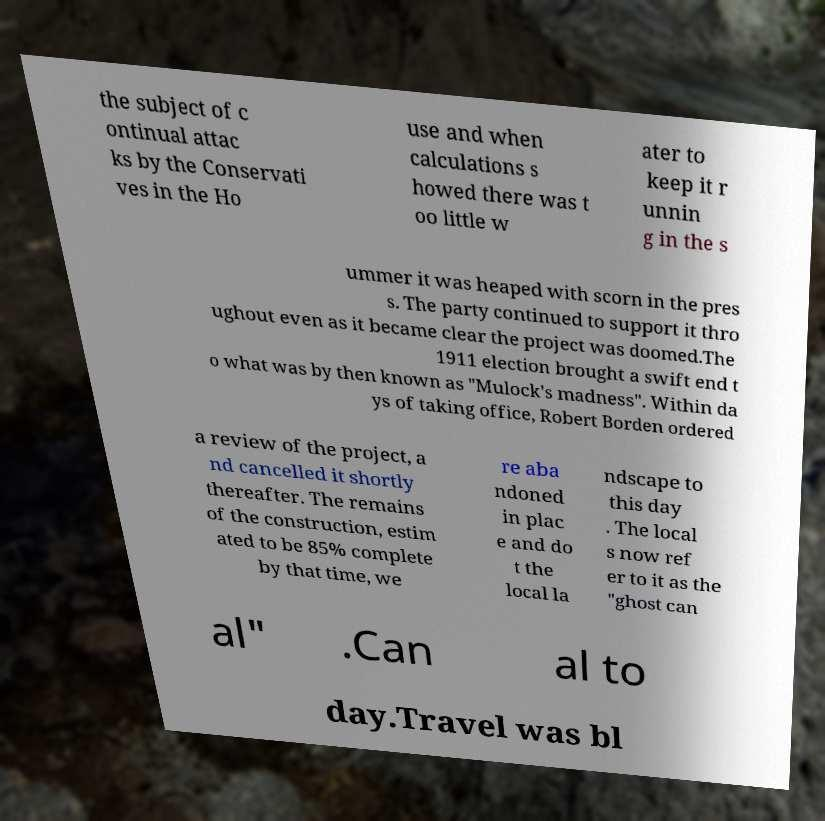I need the written content from this picture converted into text. Can you do that? the subject of c ontinual attac ks by the Conservati ves in the Ho use and when calculations s howed there was t oo little w ater to keep it r unnin g in the s ummer it was heaped with scorn in the pres s. The party continued to support it thro ughout even as it became clear the project was doomed.The 1911 election brought a swift end t o what was by then known as "Mulock's madness". Within da ys of taking office, Robert Borden ordered a review of the project, a nd cancelled it shortly thereafter. The remains of the construction, estim ated to be 85% complete by that time, we re aba ndoned in plac e and do t the local la ndscape to this day . The local s now ref er to it as the "ghost can al" .Can al to day.Travel was bl 